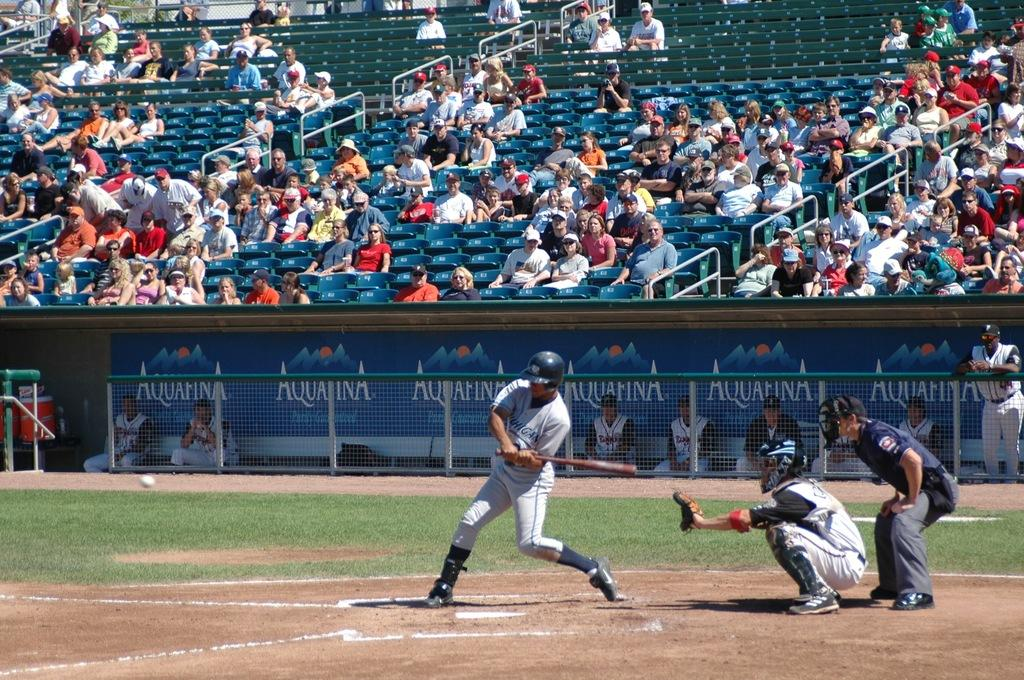<image>
Render a clear and concise summary of the photo. a baseball dug out with aquafina on the back wall 